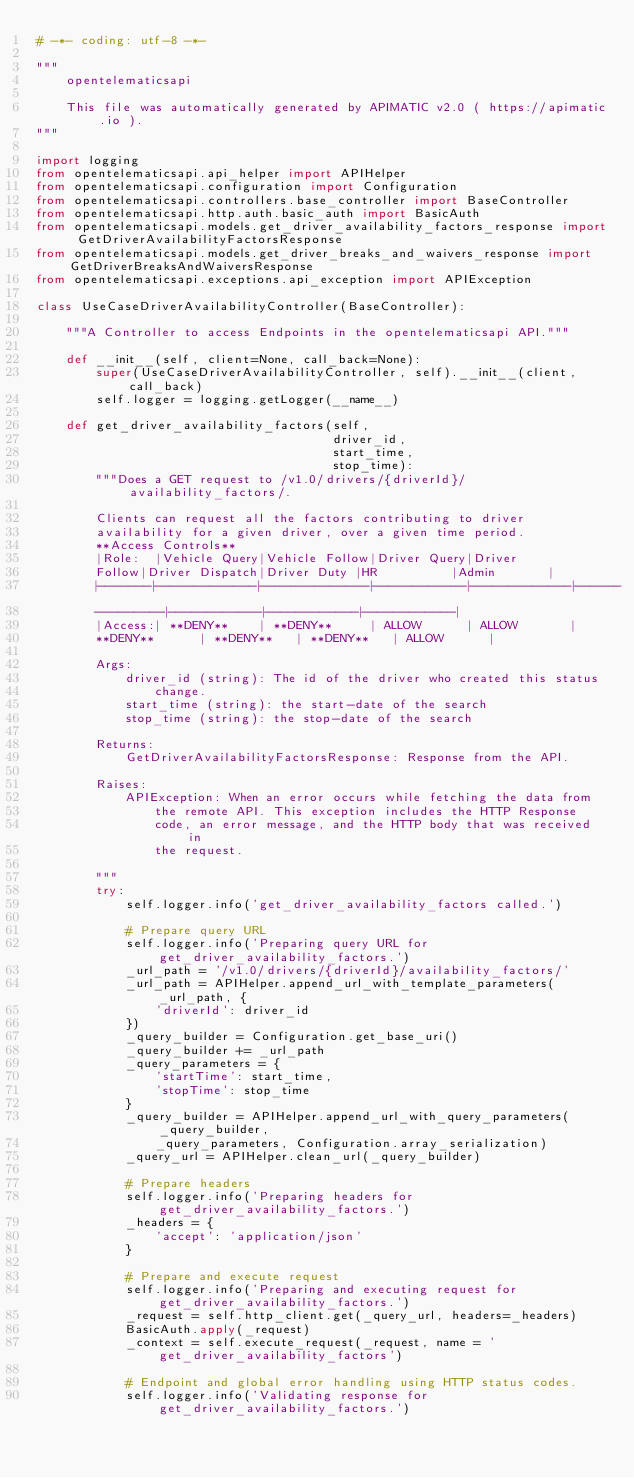Convert code to text. <code><loc_0><loc_0><loc_500><loc_500><_Python_># -*- coding: utf-8 -*-

"""
    opentelematicsapi

    This file was automatically generated by APIMATIC v2.0 ( https://apimatic.io ).
"""

import logging
from opentelematicsapi.api_helper import APIHelper
from opentelematicsapi.configuration import Configuration
from opentelematicsapi.controllers.base_controller import BaseController
from opentelematicsapi.http.auth.basic_auth import BasicAuth
from opentelematicsapi.models.get_driver_availability_factors_response import GetDriverAvailabilityFactorsResponse
from opentelematicsapi.models.get_driver_breaks_and_waivers_response import GetDriverBreaksAndWaiversResponse
from opentelematicsapi.exceptions.api_exception import APIException

class UseCaseDriverAvailabilityController(BaseController):

    """A Controller to access Endpoints in the opentelematicsapi API."""

    def __init__(self, client=None, call_back=None):
        super(UseCaseDriverAvailabilityController, self).__init__(client, call_back)
        self.logger = logging.getLogger(__name__)

    def get_driver_availability_factors(self,
                                        driver_id,
                                        start_time,
                                        stop_time):
        """Does a GET request to /v1.0/drivers/{driverId}/availability_factors/.

        Clients can request all the factors contributing to driver
        availability for a given driver, over a given time period.
        **Access Controls**
        |Role:  |Vehicle Query|Vehicle Follow|Driver Query|Driver
        Follow|Driver Dispatch|Driver Duty |HR          |Admin       |
        |-------|-------------|--------------|------------|-------------|------
        ---------|------------|------------|------------|
        |Access:| **DENY**    | **DENY**     | ALLOW      | ALLOW       |
        **DENY**      | **DENY**   | **DENY**   | ALLOW      |

        Args:
            driver_id (string): The id of the driver who created this status
                change.
            start_time (string): the start-date of the search
            stop_time (string): the stop-date of the search

        Returns:
            GetDriverAvailabilityFactorsResponse: Response from the API. 

        Raises:
            APIException: When an error occurs while fetching the data from
                the remote API. This exception includes the HTTP Response
                code, an error message, and the HTTP body that was received in
                the request.

        """
        try:
            self.logger.info('get_driver_availability_factors called.')
    
            # Prepare query URL
            self.logger.info('Preparing query URL for get_driver_availability_factors.')
            _url_path = '/v1.0/drivers/{driverId}/availability_factors/'
            _url_path = APIHelper.append_url_with_template_parameters(_url_path, { 
                'driverId': driver_id
            })
            _query_builder = Configuration.get_base_uri()
            _query_builder += _url_path
            _query_parameters = {
                'startTime': start_time,
                'stopTime': stop_time
            }
            _query_builder = APIHelper.append_url_with_query_parameters(_query_builder,
                _query_parameters, Configuration.array_serialization)
            _query_url = APIHelper.clean_url(_query_builder)
    
            # Prepare headers
            self.logger.info('Preparing headers for get_driver_availability_factors.')
            _headers = {
                'accept': 'application/json'
            }
    
            # Prepare and execute request
            self.logger.info('Preparing and executing request for get_driver_availability_factors.')
            _request = self.http_client.get(_query_url, headers=_headers)
            BasicAuth.apply(_request)
            _context = self.execute_request(_request, name = 'get_driver_availability_factors')

            # Endpoint and global error handling using HTTP status codes.
            self.logger.info('Validating response for get_driver_availability_factors.')</code> 